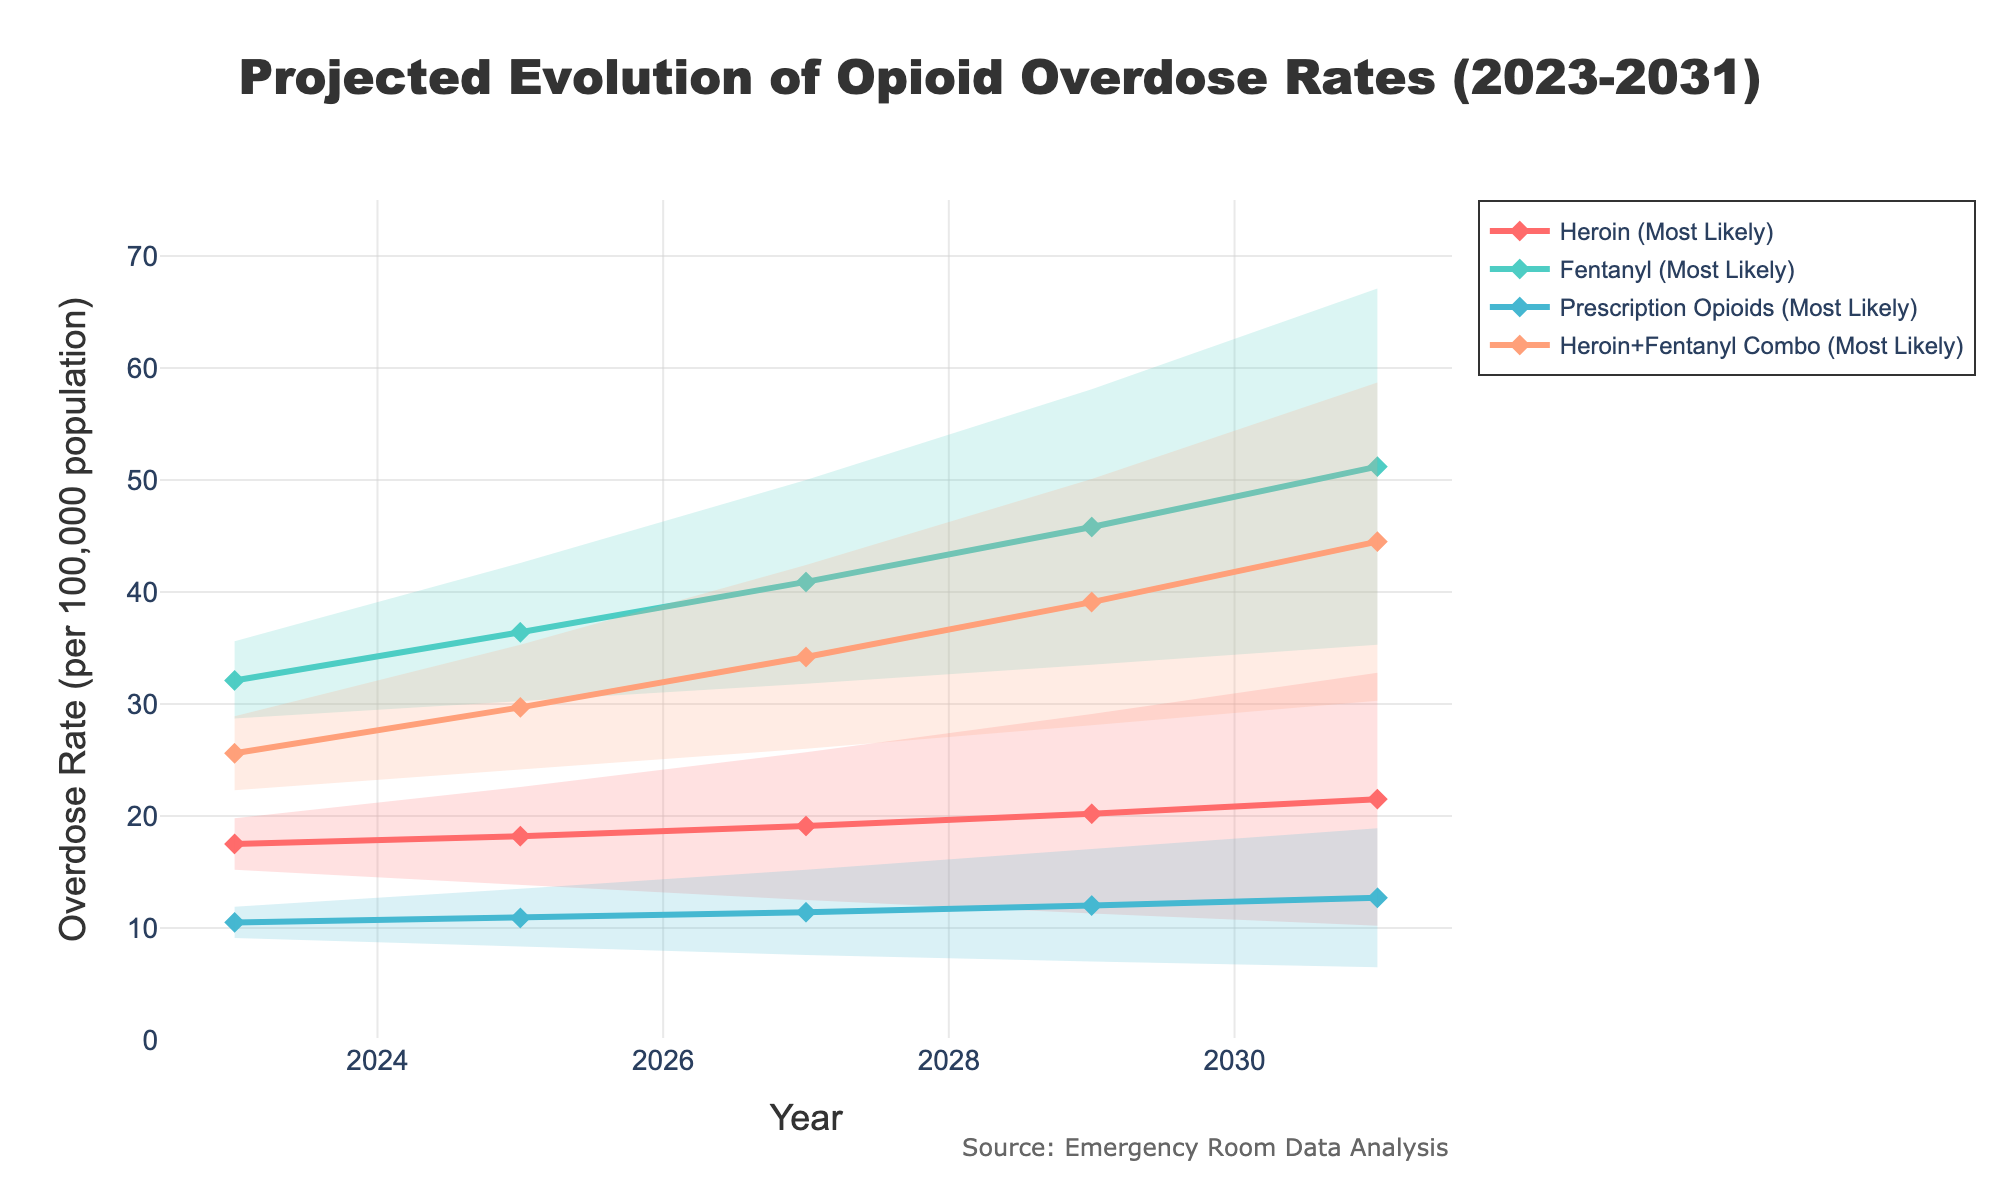What is the title of the chart? The title of the chart is located at the top and usually in a larger and bolder font compared to other text elements. It gives a brief and clear description of what the chart represents.
Answer: Projected Evolution of Opioid Overdose Rates (2023-2031) What is the projected overdose rate for Fentanyl in the most likely scenario for the year 2027? Locate the line corresponding to the most likely scenario for Fentanyl (color-coded) and look at the y-axis value where it intersects with the x-axis value for the year 2027.
Answer: 40.9 How does the projected overdose rate of heroin in the worst-case scenario for 2031 compare to the best-case scenario for the same drug and year? Identify the points for heroin in both the worst-case and best-case scenarios for 2031. The worst-case scenario is represented by the highest value while the best-case scenario is represented by the lowest value. Compare these two values directly.
Answer: 32.8 vs 10.2 What is the range of projected overdose rates for Prescription Opioids in 2025? The range is defined as the difference between the worst-case and best-case scenarios. For Prescription Opioids in 2025, subtract the best-case value from the worst-case value.
Answer: 13.5 - 8.3 = 5.2 What can be inferred about the trend of overdose rates for Heroin in the most likely scenario from 2023 to 2031? Observe the trend line for Heroin in the most likely scenario from the beginning (2023) to the end (2031). Note if it is increasing, decreasing, or stays stable.
Answer: Increasing Compare the projected overdose rates in 2029 for Heroin+Fentanyl Combo in the best case and most likely scenarios. Which is higher and by how much? Locate the projected overdose rates for Heroin+Fentanyl Combo in both best-case and most likely scenarios for 2029. Subtract the best-case value from the most likely value.
Answer: 39.1 is higher by 39.1 - 28.1 = 11.0 What is the color used for the most likely scenario line representing Prescription Opioids? Identify the line color associated with the most likely scenario of Prescription Opioids. Each drug has a distinct color.
Answer: #45B7D1 How do the projected rates for Fentanyl in the best case compare from 2023 to 2031? Compare the values of Fentanyl overdose rates in the best-case scenario at the years 2023 and 2031. Note if the rates are increasing, decreasing, or staying the same.
Answer: Increasing from 28.7 to 35.3 Which drug has the highest projected overdose rate in the most likely scenario for 2031, and what is that rate? Identify the rates for all drugs in the most likely scenario for 2031. Determine the highest rate among them.
Answer: Fentanyl, 51.2 What is the overall trend for Prescription Opioids in the worst-case scenario from 2023 to 2031? Observe the line for Prescription Opioids in the worst-case scenario throughout the specified years and describe whether it is increasing, decreasing, or remaining stable over time.
Answer: Increasing 